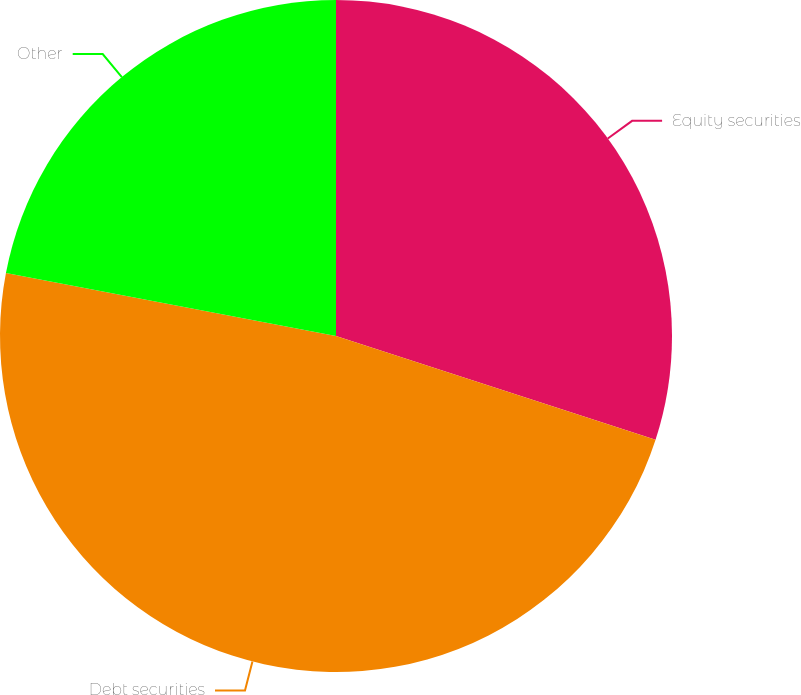<chart> <loc_0><loc_0><loc_500><loc_500><pie_chart><fcel>Equity securities<fcel>Debt securities<fcel>Other<nl><fcel>30.0%<fcel>48.0%<fcel>22.0%<nl></chart> 